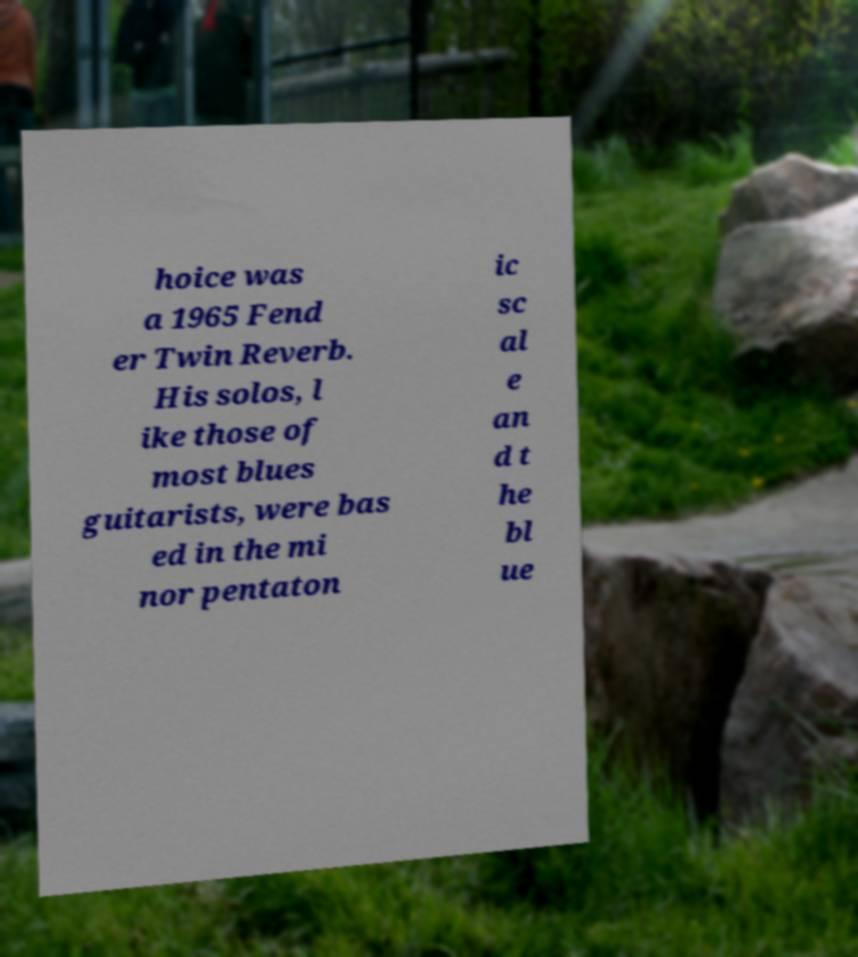What messages or text are displayed in this image? I need them in a readable, typed format. hoice was a 1965 Fend er Twin Reverb. His solos, l ike those of most blues guitarists, were bas ed in the mi nor pentaton ic sc al e an d t he bl ue 